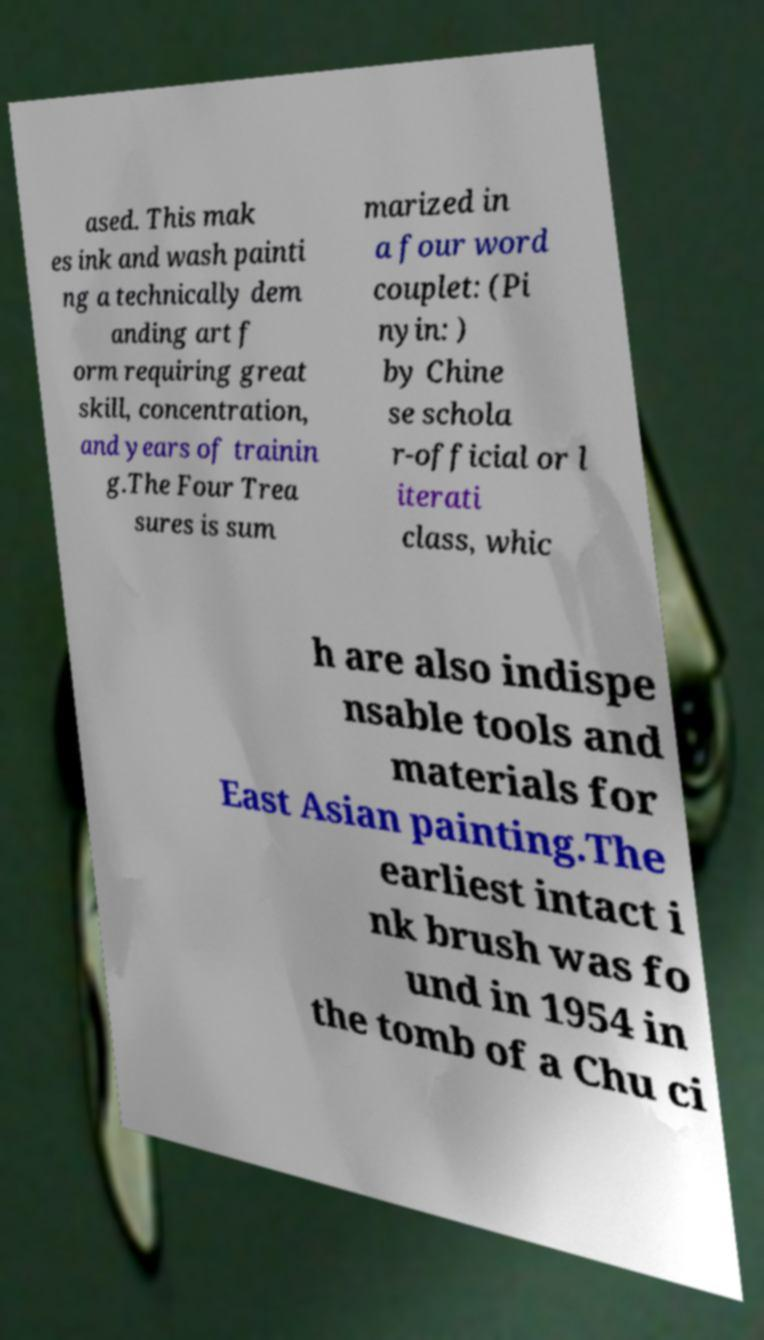Can you accurately transcribe the text from the provided image for me? ased. This mak es ink and wash painti ng a technically dem anding art f orm requiring great skill, concentration, and years of trainin g.The Four Trea sures is sum marized in a four word couplet: (Pi nyin: ) by Chine se schola r-official or l iterati class, whic h are also indispe nsable tools and materials for East Asian painting.The earliest intact i nk brush was fo und in 1954 in the tomb of a Chu ci 